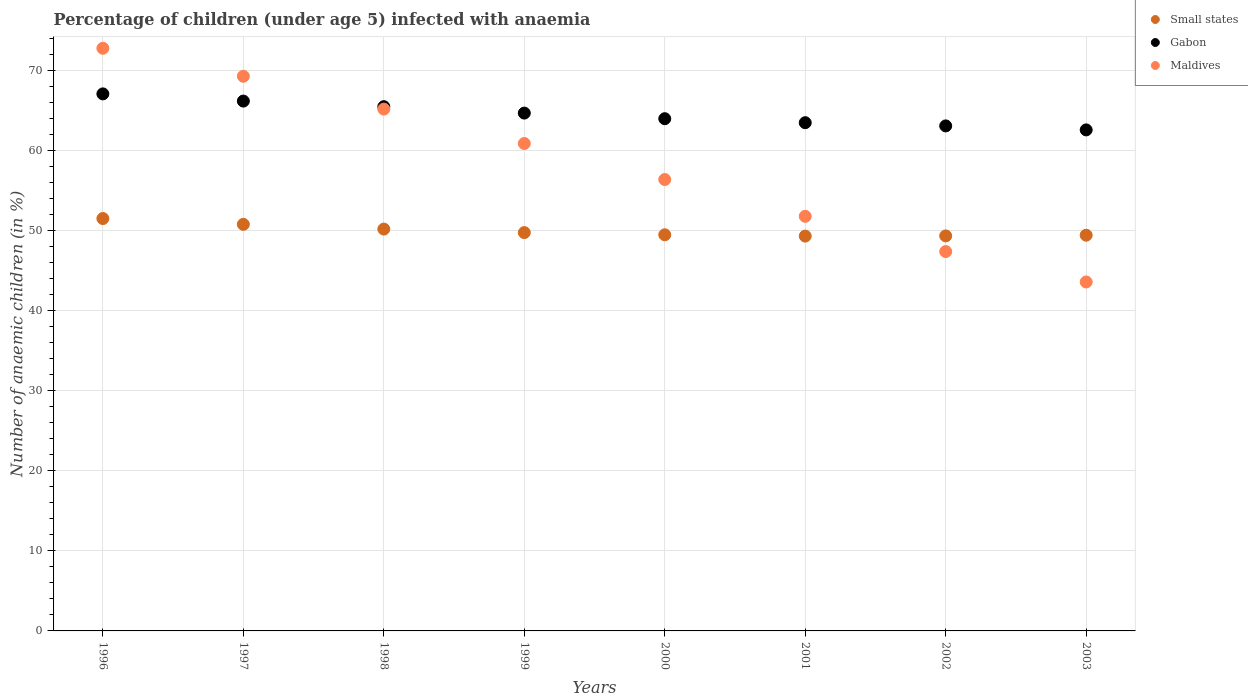What is the percentage of children infected with anaemia in in Small states in 2000?
Make the answer very short. 49.49. Across all years, what is the maximum percentage of children infected with anaemia in in Maldives?
Your answer should be very brief. 72.8. Across all years, what is the minimum percentage of children infected with anaemia in in Small states?
Your answer should be compact. 49.33. In which year was the percentage of children infected with anaemia in in Maldives maximum?
Keep it short and to the point. 1996. In which year was the percentage of children infected with anaemia in in Small states minimum?
Ensure brevity in your answer.  2001. What is the total percentage of children infected with anaemia in in Maldives in the graph?
Your response must be concise. 467.4. What is the difference between the percentage of children infected with anaemia in in Maldives in 1996 and that in 1997?
Your answer should be compact. 3.5. What is the difference between the percentage of children infected with anaemia in in Small states in 2003 and the percentage of children infected with anaemia in in Maldives in 1997?
Your answer should be very brief. -19.86. What is the average percentage of children infected with anaemia in in Maldives per year?
Provide a short and direct response. 58.42. In the year 1998, what is the difference between the percentage of children infected with anaemia in in Small states and percentage of children infected with anaemia in in Maldives?
Keep it short and to the point. -14.99. In how many years, is the percentage of children infected with anaemia in in Small states greater than 16 %?
Your answer should be compact. 8. What is the ratio of the percentage of children infected with anaemia in in Gabon in 1997 to that in 1999?
Provide a short and direct response. 1.02. Is the difference between the percentage of children infected with anaemia in in Small states in 1996 and 1998 greater than the difference between the percentage of children infected with anaemia in in Maldives in 1996 and 1998?
Offer a terse response. No. What is the difference between the highest and the second highest percentage of children infected with anaemia in in Small states?
Give a very brief answer. 0.73. What is the difference between the highest and the lowest percentage of children infected with anaemia in in Gabon?
Your answer should be very brief. 4.5. Does the percentage of children infected with anaemia in in Gabon monotonically increase over the years?
Offer a terse response. No. Is the percentage of children infected with anaemia in in Small states strictly less than the percentage of children infected with anaemia in in Maldives over the years?
Your answer should be compact. No. What is the difference between two consecutive major ticks on the Y-axis?
Your response must be concise. 10. Does the graph contain grids?
Offer a very short reply. Yes. Where does the legend appear in the graph?
Offer a terse response. Top right. How many legend labels are there?
Ensure brevity in your answer.  3. What is the title of the graph?
Provide a succinct answer. Percentage of children (under age 5) infected with anaemia. What is the label or title of the X-axis?
Provide a short and direct response. Years. What is the label or title of the Y-axis?
Keep it short and to the point. Number of anaemic children (in %). What is the Number of anaemic children (in %) of Small states in 1996?
Give a very brief answer. 51.52. What is the Number of anaemic children (in %) of Gabon in 1996?
Give a very brief answer. 67.1. What is the Number of anaemic children (in %) in Maldives in 1996?
Keep it short and to the point. 72.8. What is the Number of anaemic children (in %) in Small states in 1997?
Provide a succinct answer. 50.8. What is the Number of anaemic children (in %) in Gabon in 1997?
Make the answer very short. 66.2. What is the Number of anaemic children (in %) of Maldives in 1997?
Keep it short and to the point. 69.3. What is the Number of anaemic children (in %) of Small states in 1998?
Ensure brevity in your answer.  50.21. What is the Number of anaemic children (in %) of Gabon in 1998?
Your answer should be very brief. 65.5. What is the Number of anaemic children (in %) of Maldives in 1998?
Your response must be concise. 65.2. What is the Number of anaemic children (in %) of Small states in 1999?
Ensure brevity in your answer.  49.77. What is the Number of anaemic children (in %) in Gabon in 1999?
Your answer should be very brief. 64.7. What is the Number of anaemic children (in %) of Maldives in 1999?
Provide a short and direct response. 60.9. What is the Number of anaemic children (in %) in Small states in 2000?
Make the answer very short. 49.49. What is the Number of anaemic children (in %) in Maldives in 2000?
Your response must be concise. 56.4. What is the Number of anaemic children (in %) in Small states in 2001?
Make the answer very short. 49.33. What is the Number of anaemic children (in %) of Gabon in 2001?
Give a very brief answer. 63.5. What is the Number of anaemic children (in %) of Maldives in 2001?
Keep it short and to the point. 51.8. What is the Number of anaemic children (in %) of Small states in 2002?
Your response must be concise. 49.36. What is the Number of anaemic children (in %) of Gabon in 2002?
Make the answer very short. 63.1. What is the Number of anaemic children (in %) of Maldives in 2002?
Provide a short and direct response. 47.4. What is the Number of anaemic children (in %) in Small states in 2003?
Make the answer very short. 49.44. What is the Number of anaemic children (in %) in Gabon in 2003?
Keep it short and to the point. 62.6. What is the Number of anaemic children (in %) of Maldives in 2003?
Offer a terse response. 43.6. Across all years, what is the maximum Number of anaemic children (in %) of Small states?
Make the answer very short. 51.52. Across all years, what is the maximum Number of anaemic children (in %) in Gabon?
Offer a terse response. 67.1. Across all years, what is the maximum Number of anaemic children (in %) of Maldives?
Your answer should be compact. 72.8. Across all years, what is the minimum Number of anaemic children (in %) of Small states?
Your answer should be very brief. 49.33. Across all years, what is the minimum Number of anaemic children (in %) of Gabon?
Your response must be concise. 62.6. Across all years, what is the minimum Number of anaemic children (in %) in Maldives?
Provide a succinct answer. 43.6. What is the total Number of anaemic children (in %) in Small states in the graph?
Provide a succinct answer. 399.92. What is the total Number of anaemic children (in %) in Gabon in the graph?
Your answer should be compact. 516.7. What is the total Number of anaemic children (in %) of Maldives in the graph?
Keep it short and to the point. 467.4. What is the difference between the Number of anaemic children (in %) in Small states in 1996 and that in 1997?
Your response must be concise. 0.73. What is the difference between the Number of anaemic children (in %) in Gabon in 1996 and that in 1997?
Your answer should be very brief. 0.9. What is the difference between the Number of anaemic children (in %) in Small states in 1996 and that in 1998?
Provide a succinct answer. 1.32. What is the difference between the Number of anaemic children (in %) in Gabon in 1996 and that in 1998?
Keep it short and to the point. 1.6. What is the difference between the Number of anaemic children (in %) in Small states in 1996 and that in 1999?
Offer a very short reply. 1.76. What is the difference between the Number of anaemic children (in %) of Gabon in 1996 and that in 1999?
Your answer should be compact. 2.4. What is the difference between the Number of anaemic children (in %) of Small states in 1996 and that in 2000?
Keep it short and to the point. 2.03. What is the difference between the Number of anaemic children (in %) of Gabon in 1996 and that in 2000?
Provide a succinct answer. 3.1. What is the difference between the Number of anaemic children (in %) in Maldives in 1996 and that in 2000?
Make the answer very short. 16.4. What is the difference between the Number of anaemic children (in %) in Small states in 1996 and that in 2001?
Make the answer very short. 2.19. What is the difference between the Number of anaemic children (in %) in Small states in 1996 and that in 2002?
Offer a very short reply. 2.17. What is the difference between the Number of anaemic children (in %) in Gabon in 1996 and that in 2002?
Your answer should be compact. 4. What is the difference between the Number of anaemic children (in %) of Maldives in 1996 and that in 2002?
Your response must be concise. 25.4. What is the difference between the Number of anaemic children (in %) in Small states in 1996 and that in 2003?
Your answer should be compact. 2.08. What is the difference between the Number of anaemic children (in %) in Gabon in 1996 and that in 2003?
Your response must be concise. 4.5. What is the difference between the Number of anaemic children (in %) of Maldives in 1996 and that in 2003?
Provide a succinct answer. 29.2. What is the difference between the Number of anaemic children (in %) in Small states in 1997 and that in 1998?
Provide a succinct answer. 0.59. What is the difference between the Number of anaemic children (in %) in Gabon in 1997 and that in 1998?
Your answer should be very brief. 0.7. What is the difference between the Number of anaemic children (in %) in Maldives in 1997 and that in 1998?
Give a very brief answer. 4.1. What is the difference between the Number of anaemic children (in %) of Small states in 1997 and that in 1999?
Make the answer very short. 1.03. What is the difference between the Number of anaemic children (in %) in Gabon in 1997 and that in 1999?
Make the answer very short. 1.5. What is the difference between the Number of anaemic children (in %) in Small states in 1997 and that in 2000?
Your response must be concise. 1.3. What is the difference between the Number of anaemic children (in %) of Maldives in 1997 and that in 2000?
Offer a terse response. 12.9. What is the difference between the Number of anaemic children (in %) in Small states in 1997 and that in 2001?
Your response must be concise. 1.46. What is the difference between the Number of anaemic children (in %) in Maldives in 1997 and that in 2001?
Your response must be concise. 17.5. What is the difference between the Number of anaemic children (in %) of Small states in 1997 and that in 2002?
Your response must be concise. 1.44. What is the difference between the Number of anaemic children (in %) of Maldives in 1997 and that in 2002?
Make the answer very short. 21.9. What is the difference between the Number of anaemic children (in %) in Small states in 1997 and that in 2003?
Provide a succinct answer. 1.36. What is the difference between the Number of anaemic children (in %) of Gabon in 1997 and that in 2003?
Offer a terse response. 3.6. What is the difference between the Number of anaemic children (in %) in Maldives in 1997 and that in 2003?
Your answer should be compact. 25.7. What is the difference between the Number of anaemic children (in %) in Small states in 1998 and that in 1999?
Provide a succinct answer. 0.44. What is the difference between the Number of anaemic children (in %) of Gabon in 1998 and that in 1999?
Ensure brevity in your answer.  0.8. What is the difference between the Number of anaemic children (in %) in Maldives in 1998 and that in 1999?
Offer a terse response. 4.3. What is the difference between the Number of anaemic children (in %) of Small states in 1998 and that in 2000?
Your answer should be compact. 0.71. What is the difference between the Number of anaemic children (in %) of Small states in 1998 and that in 2001?
Your response must be concise. 0.87. What is the difference between the Number of anaemic children (in %) in Small states in 1998 and that in 2002?
Keep it short and to the point. 0.85. What is the difference between the Number of anaemic children (in %) of Small states in 1998 and that in 2003?
Offer a very short reply. 0.76. What is the difference between the Number of anaemic children (in %) of Gabon in 1998 and that in 2003?
Ensure brevity in your answer.  2.9. What is the difference between the Number of anaemic children (in %) in Maldives in 1998 and that in 2003?
Offer a very short reply. 21.6. What is the difference between the Number of anaemic children (in %) of Small states in 1999 and that in 2000?
Give a very brief answer. 0.27. What is the difference between the Number of anaemic children (in %) of Maldives in 1999 and that in 2000?
Keep it short and to the point. 4.5. What is the difference between the Number of anaemic children (in %) of Small states in 1999 and that in 2001?
Your answer should be very brief. 0.44. What is the difference between the Number of anaemic children (in %) in Maldives in 1999 and that in 2001?
Your answer should be very brief. 9.1. What is the difference between the Number of anaemic children (in %) in Small states in 1999 and that in 2002?
Provide a short and direct response. 0.41. What is the difference between the Number of anaemic children (in %) in Maldives in 1999 and that in 2002?
Provide a succinct answer. 13.5. What is the difference between the Number of anaemic children (in %) of Small states in 1999 and that in 2003?
Provide a short and direct response. 0.33. What is the difference between the Number of anaemic children (in %) in Maldives in 1999 and that in 2003?
Offer a very short reply. 17.3. What is the difference between the Number of anaemic children (in %) in Small states in 2000 and that in 2001?
Offer a terse response. 0.16. What is the difference between the Number of anaemic children (in %) in Gabon in 2000 and that in 2001?
Provide a short and direct response. 0.5. What is the difference between the Number of anaemic children (in %) in Maldives in 2000 and that in 2001?
Your answer should be compact. 4.6. What is the difference between the Number of anaemic children (in %) in Small states in 2000 and that in 2002?
Offer a terse response. 0.14. What is the difference between the Number of anaemic children (in %) in Small states in 2000 and that in 2003?
Ensure brevity in your answer.  0.05. What is the difference between the Number of anaemic children (in %) in Small states in 2001 and that in 2002?
Offer a very short reply. -0.02. What is the difference between the Number of anaemic children (in %) of Gabon in 2001 and that in 2002?
Make the answer very short. 0.4. What is the difference between the Number of anaemic children (in %) of Small states in 2001 and that in 2003?
Your answer should be compact. -0.11. What is the difference between the Number of anaemic children (in %) in Gabon in 2001 and that in 2003?
Your answer should be compact. 0.9. What is the difference between the Number of anaemic children (in %) of Maldives in 2001 and that in 2003?
Your answer should be very brief. 8.2. What is the difference between the Number of anaemic children (in %) of Small states in 2002 and that in 2003?
Offer a very short reply. -0.09. What is the difference between the Number of anaemic children (in %) of Small states in 1996 and the Number of anaemic children (in %) of Gabon in 1997?
Your answer should be very brief. -14.68. What is the difference between the Number of anaemic children (in %) in Small states in 1996 and the Number of anaemic children (in %) in Maldives in 1997?
Keep it short and to the point. -17.78. What is the difference between the Number of anaemic children (in %) in Gabon in 1996 and the Number of anaemic children (in %) in Maldives in 1997?
Your answer should be compact. -2.2. What is the difference between the Number of anaemic children (in %) in Small states in 1996 and the Number of anaemic children (in %) in Gabon in 1998?
Make the answer very short. -13.98. What is the difference between the Number of anaemic children (in %) of Small states in 1996 and the Number of anaemic children (in %) of Maldives in 1998?
Give a very brief answer. -13.68. What is the difference between the Number of anaemic children (in %) in Gabon in 1996 and the Number of anaemic children (in %) in Maldives in 1998?
Make the answer very short. 1.9. What is the difference between the Number of anaemic children (in %) of Small states in 1996 and the Number of anaemic children (in %) of Gabon in 1999?
Give a very brief answer. -13.18. What is the difference between the Number of anaemic children (in %) in Small states in 1996 and the Number of anaemic children (in %) in Maldives in 1999?
Ensure brevity in your answer.  -9.38. What is the difference between the Number of anaemic children (in %) in Small states in 1996 and the Number of anaemic children (in %) in Gabon in 2000?
Your answer should be compact. -12.48. What is the difference between the Number of anaemic children (in %) in Small states in 1996 and the Number of anaemic children (in %) in Maldives in 2000?
Provide a short and direct response. -4.88. What is the difference between the Number of anaemic children (in %) of Gabon in 1996 and the Number of anaemic children (in %) of Maldives in 2000?
Make the answer very short. 10.7. What is the difference between the Number of anaemic children (in %) in Small states in 1996 and the Number of anaemic children (in %) in Gabon in 2001?
Offer a very short reply. -11.98. What is the difference between the Number of anaemic children (in %) in Small states in 1996 and the Number of anaemic children (in %) in Maldives in 2001?
Make the answer very short. -0.28. What is the difference between the Number of anaemic children (in %) of Gabon in 1996 and the Number of anaemic children (in %) of Maldives in 2001?
Ensure brevity in your answer.  15.3. What is the difference between the Number of anaemic children (in %) of Small states in 1996 and the Number of anaemic children (in %) of Gabon in 2002?
Your answer should be compact. -11.58. What is the difference between the Number of anaemic children (in %) in Small states in 1996 and the Number of anaemic children (in %) in Maldives in 2002?
Your response must be concise. 4.12. What is the difference between the Number of anaemic children (in %) in Small states in 1996 and the Number of anaemic children (in %) in Gabon in 2003?
Your answer should be very brief. -11.08. What is the difference between the Number of anaemic children (in %) in Small states in 1996 and the Number of anaemic children (in %) in Maldives in 2003?
Offer a terse response. 7.92. What is the difference between the Number of anaemic children (in %) of Gabon in 1996 and the Number of anaemic children (in %) of Maldives in 2003?
Offer a terse response. 23.5. What is the difference between the Number of anaemic children (in %) in Small states in 1997 and the Number of anaemic children (in %) in Gabon in 1998?
Offer a terse response. -14.7. What is the difference between the Number of anaemic children (in %) of Small states in 1997 and the Number of anaemic children (in %) of Maldives in 1998?
Make the answer very short. -14.4. What is the difference between the Number of anaemic children (in %) of Small states in 1997 and the Number of anaemic children (in %) of Gabon in 1999?
Your response must be concise. -13.9. What is the difference between the Number of anaemic children (in %) of Small states in 1997 and the Number of anaemic children (in %) of Maldives in 1999?
Make the answer very short. -10.1. What is the difference between the Number of anaemic children (in %) in Gabon in 1997 and the Number of anaemic children (in %) in Maldives in 1999?
Your answer should be compact. 5.3. What is the difference between the Number of anaemic children (in %) of Small states in 1997 and the Number of anaemic children (in %) of Gabon in 2000?
Make the answer very short. -13.2. What is the difference between the Number of anaemic children (in %) in Small states in 1997 and the Number of anaemic children (in %) in Maldives in 2000?
Provide a short and direct response. -5.6. What is the difference between the Number of anaemic children (in %) in Small states in 1997 and the Number of anaemic children (in %) in Gabon in 2001?
Offer a terse response. -12.7. What is the difference between the Number of anaemic children (in %) in Small states in 1997 and the Number of anaemic children (in %) in Maldives in 2001?
Your answer should be very brief. -1. What is the difference between the Number of anaemic children (in %) of Gabon in 1997 and the Number of anaemic children (in %) of Maldives in 2001?
Keep it short and to the point. 14.4. What is the difference between the Number of anaemic children (in %) in Small states in 1997 and the Number of anaemic children (in %) in Gabon in 2002?
Provide a short and direct response. -12.3. What is the difference between the Number of anaemic children (in %) in Small states in 1997 and the Number of anaemic children (in %) in Maldives in 2002?
Give a very brief answer. 3.4. What is the difference between the Number of anaemic children (in %) of Gabon in 1997 and the Number of anaemic children (in %) of Maldives in 2002?
Give a very brief answer. 18.8. What is the difference between the Number of anaemic children (in %) of Small states in 1997 and the Number of anaemic children (in %) of Gabon in 2003?
Ensure brevity in your answer.  -11.8. What is the difference between the Number of anaemic children (in %) in Small states in 1997 and the Number of anaemic children (in %) in Maldives in 2003?
Your answer should be very brief. 7.2. What is the difference between the Number of anaemic children (in %) of Gabon in 1997 and the Number of anaemic children (in %) of Maldives in 2003?
Provide a short and direct response. 22.6. What is the difference between the Number of anaemic children (in %) in Small states in 1998 and the Number of anaemic children (in %) in Gabon in 1999?
Your response must be concise. -14.49. What is the difference between the Number of anaemic children (in %) in Small states in 1998 and the Number of anaemic children (in %) in Maldives in 1999?
Offer a terse response. -10.69. What is the difference between the Number of anaemic children (in %) in Gabon in 1998 and the Number of anaemic children (in %) in Maldives in 1999?
Provide a short and direct response. 4.6. What is the difference between the Number of anaemic children (in %) in Small states in 1998 and the Number of anaemic children (in %) in Gabon in 2000?
Give a very brief answer. -13.79. What is the difference between the Number of anaemic children (in %) of Small states in 1998 and the Number of anaemic children (in %) of Maldives in 2000?
Your answer should be very brief. -6.19. What is the difference between the Number of anaemic children (in %) of Small states in 1998 and the Number of anaemic children (in %) of Gabon in 2001?
Offer a terse response. -13.29. What is the difference between the Number of anaemic children (in %) in Small states in 1998 and the Number of anaemic children (in %) in Maldives in 2001?
Keep it short and to the point. -1.59. What is the difference between the Number of anaemic children (in %) of Small states in 1998 and the Number of anaemic children (in %) of Gabon in 2002?
Offer a very short reply. -12.89. What is the difference between the Number of anaemic children (in %) in Small states in 1998 and the Number of anaemic children (in %) in Maldives in 2002?
Keep it short and to the point. 2.81. What is the difference between the Number of anaemic children (in %) of Small states in 1998 and the Number of anaemic children (in %) of Gabon in 2003?
Ensure brevity in your answer.  -12.39. What is the difference between the Number of anaemic children (in %) in Small states in 1998 and the Number of anaemic children (in %) in Maldives in 2003?
Offer a terse response. 6.61. What is the difference between the Number of anaemic children (in %) of Gabon in 1998 and the Number of anaemic children (in %) of Maldives in 2003?
Ensure brevity in your answer.  21.9. What is the difference between the Number of anaemic children (in %) in Small states in 1999 and the Number of anaemic children (in %) in Gabon in 2000?
Your answer should be very brief. -14.23. What is the difference between the Number of anaemic children (in %) of Small states in 1999 and the Number of anaemic children (in %) of Maldives in 2000?
Your response must be concise. -6.63. What is the difference between the Number of anaemic children (in %) of Small states in 1999 and the Number of anaemic children (in %) of Gabon in 2001?
Offer a terse response. -13.73. What is the difference between the Number of anaemic children (in %) in Small states in 1999 and the Number of anaemic children (in %) in Maldives in 2001?
Your response must be concise. -2.03. What is the difference between the Number of anaemic children (in %) in Small states in 1999 and the Number of anaemic children (in %) in Gabon in 2002?
Your answer should be very brief. -13.33. What is the difference between the Number of anaemic children (in %) of Small states in 1999 and the Number of anaemic children (in %) of Maldives in 2002?
Your answer should be very brief. 2.37. What is the difference between the Number of anaemic children (in %) in Small states in 1999 and the Number of anaemic children (in %) in Gabon in 2003?
Keep it short and to the point. -12.83. What is the difference between the Number of anaemic children (in %) of Small states in 1999 and the Number of anaemic children (in %) of Maldives in 2003?
Your answer should be very brief. 6.17. What is the difference between the Number of anaemic children (in %) of Gabon in 1999 and the Number of anaemic children (in %) of Maldives in 2003?
Provide a short and direct response. 21.1. What is the difference between the Number of anaemic children (in %) of Small states in 2000 and the Number of anaemic children (in %) of Gabon in 2001?
Your answer should be compact. -14.01. What is the difference between the Number of anaemic children (in %) in Small states in 2000 and the Number of anaemic children (in %) in Maldives in 2001?
Offer a terse response. -2.31. What is the difference between the Number of anaemic children (in %) of Small states in 2000 and the Number of anaemic children (in %) of Gabon in 2002?
Give a very brief answer. -13.61. What is the difference between the Number of anaemic children (in %) of Small states in 2000 and the Number of anaemic children (in %) of Maldives in 2002?
Make the answer very short. 2.09. What is the difference between the Number of anaemic children (in %) of Small states in 2000 and the Number of anaemic children (in %) of Gabon in 2003?
Keep it short and to the point. -13.11. What is the difference between the Number of anaemic children (in %) in Small states in 2000 and the Number of anaemic children (in %) in Maldives in 2003?
Your response must be concise. 5.89. What is the difference between the Number of anaemic children (in %) of Gabon in 2000 and the Number of anaemic children (in %) of Maldives in 2003?
Offer a terse response. 20.4. What is the difference between the Number of anaemic children (in %) in Small states in 2001 and the Number of anaemic children (in %) in Gabon in 2002?
Offer a very short reply. -13.77. What is the difference between the Number of anaemic children (in %) in Small states in 2001 and the Number of anaemic children (in %) in Maldives in 2002?
Ensure brevity in your answer.  1.93. What is the difference between the Number of anaemic children (in %) of Gabon in 2001 and the Number of anaemic children (in %) of Maldives in 2002?
Ensure brevity in your answer.  16.1. What is the difference between the Number of anaemic children (in %) in Small states in 2001 and the Number of anaemic children (in %) in Gabon in 2003?
Provide a short and direct response. -13.27. What is the difference between the Number of anaemic children (in %) in Small states in 2001 and the Number of anaemic children (in %) in Maldives in 2003?
Your response must be concise. 5.73. What is the difference between the Number of anaemic children (in %) in Gabon in 2001 and the Number of anaemic children (in %) in Maldives in 2003?
Give a very brief answer. 19.9. What is the difference between the Number of anaemic children (in %) in Small states in 2002 and the Number of anaemic children (in %) in Gabon in 2003?
Offer a terse response. -13.24. What is the difference between the Number of anaemic children (in %) in Small states in 2002 and the Number of anaemic children (in %) in Maldives in 2003?
Give a very brief answer. 5.76. What is the average Number of anaemic children (in %) of Small states per year?
Your response must be concise. 49.99. What is the average Number of anaemic children (in %) in Gabon per year?
Your response must be concise. 64.59. What is the average Number of anaemic children (in %) in Maldives per year?
Offer a very short reply. 58.42. In the year 1996, what is the difference between the Number of anaemic children (in %) in Small states and Number of anaemic children (in %) in Gabon?
Give a very brief answer. -15.58. In the year 1996, what is the difference between the Number of anaemic children (in %) of Small states and Number of anaemic children (in %) of Maldives?
Offer a very short reply. -21.28. In the year 1996, what is the difference between the Number of anaemic children (in %) of Gabon and Number of anaemic children (in %) of Maldives?
Keep it short and to the point. -5.7. In the year 1997, what is the difference between the Number of anaemic children (in %) of Small states and Number of anaemic children (in %) of Gabon?
Provide a short and direct response. -15.4. In the year 1997, what is the difference between the Number of anaemic children (in %) in Small states and Number of anaemic children (in %) in Maldives?
Make the answer very short. -18.5. In the year 1997, what is the difference between the Number of anaemic children (in %) in Gabon and Number of anaemic children (in %) in Maldives?
Offer a terse response. -3.1. In the year 1998, what is the difference between the Number of anaemic children (in %) of Small states and Number of anaemic children (in %) of Gabon?
Your answer should be compact. -15.29. In the year 1998, what is the difference between the Number of anaemic children (in %) in Small states and Number of anaemic children (in %) in Maldives?
Ensure brevity in your answer.  -14.99. In the year 1999, what is the difference between the Number of anaemic children (in %) of Small states and Number of anaemic children (in %) of Gabon?
Provide a succinct answer. -14.93. In the year 1999, what is the difference between the Number of anaemic children (in %) in Small states and Number of anaemic children (in %) in Maldives?
Make the answer very short. -11.13. In the year 1999, what is the difference between the Number of anaemic children (in %) of Gabon and Number of anaemic children (in %) of Maldives?
Keep it short and to the point. 3.8. In the year 2000, what is the difference between the Number of anaemic children (in %) of Small states and Number of anaemic children (in %) of Gabon?
Ensure brevity in your answer.  -14.51. In the year 2000, what is the difference between the Number of anaemic children (in %) of Small states and Number of anaemic children (in %) of Maldives?
Your answer should be compact. -6.91. In the year 2001, what is the difference between the Number of anaemic children (in %) of Small states and Number of anaemic children (in %) of Gabon?
Make the answer very short. -14.17. In the year 2001, what is the difference between the Number of anaemic children (in %) of Small states and Number of anaemic children (in %) of Maldives?
Provide a short and direct response. -2.47. In the year 2002, what is the difference between the Number of anaemic children (in %) in Small states and Number of anaemic children (in %) in Gabon?
Offer a terse response. -13.74. In the year 2002, what is the difference between the Number of anaemic children (in %) in Small states and Number of anaemic children (in %) in Maldives?
Provide a short and direct response. 1.96. In the year 2003, what is the difference between the Number of anaemic children (in %) in Small states and Number of anaemic children (in %) in Gabon?
Offer a very short reply. -13.16. In the year 2003, what is the difference between the Number of anaemic children (in %) of Small states and Number of anaemic children (in %) of Maldives?
Give a very brief answer. 5.84. In the year 2003, what is the difference between the Number of anaemic children (in %) of Gabon and Number of anaemic children (in %) of Maldives?
Ensure brevity in your answer.  19. What is the ratio of the Number of anaemic children (in %) in Small states in 1996 to that in 1997?
Keep it short and to the point. 1.01. What is the ratio of the Number of anaemic children (in %) of Gabon in 1996 to that in 1997?
Offer a terse response. 1.01. What is the ratio of the Number of anaemic children (in %) of Maldives in 1996 to that in 1997?
Make the answer very short. 1.05. What is the ratio of the Number of anaemic children (in %) in Small states in 1996 to that in 1998?
Ensure brevity in your answer.  1.03. What is the ratio of the Number of anaemic children (in %) in Gabon in 1996 to that in 1998?
Make the answer very short. 1.02. What is the ratio of the Number of anaemic children (in %) in Maldives in 1996 to that in 1998?
Your answer should be very brief. 1.12. What is the ratio of the Number of anaemic children (in %) in Small states in 1996 to that in 1999?
Ensure brevity in your answer.  1.04. What is the ratio of the Number of anaemic children (in %) of Gabon in 1996 to that in 1999?
Your answer should be compact. 1.04. What is the ratio of the Number of anaemic children (in %) of Maldives in 1996 to that in 1999?
Give a very brief answer. 1.2. What is the ratio of the Number of anaemic children (in %) in Small states in 1996 to that in 2000?
Give a very brief answer. 1.04. What is the ratio of the Number of anaemic children (in %) in Gabon in 1996 to that in 2000?
Your response must be concise. 1.05. What is the ratio of the Number of anaemic children (in %) in Maldives in 1996 to that in 2000?
Your answer should be compact. 1.29. What is the ratio of the Number of anaemic children (in %) in Small states in 1996 to that in 2001?
Offer a terse response. 1.04. What is the ratio of the Number of anaemic children (in %) in Gabon in 1996 to that in 2001?
Keep it short and to the point. 1.06. What is the ratio of the Number of anaemic children (in %) of Maldives in 1996 to that in 2001?
Ensure brevity in your answer.  1.41. What is the ratio of the Number of anaemic children (in %) of Small states in 1996 to that in 2002?
Give a very brief answer. 1.04. What is the ratio of the Number of anaemic children (in %) in Gabon in 1996 to that in 2002?
Provide a succinct answer. 1.06. What is the ratio of the Number of anaemic children (in %) of Maldives in 1996 to that in 2002?
Make the answer very short. 1.54. What is the ratio of the Number of anaemic children (in %) of Small states in 1996 to that in 2003?
Offer a very short reply. 1.04. What is the ratio of the Number of anaemic children (in %) of Gabon in 1996 to that in 2003?
Provide a succinct answer. 1.07. What is the ratio of the Number of anaemic children (in %) in Maldives in 1996 to that in 2003?
Keep it short and to the point. 1.67. What is the ratio of the Number of anaemic children (in %) in Small states in 1997 to that in 1998?
Your response must be concise. 1.01. What is the ratio of the Number of anaemic children (in %) in Gabon in 1997 to that in 1998?
Your answer should be compact. 1.01. What is the ratio of the Number of anaemic children (in %) in Maldives in 1997 to that in 1998?
Ensure brevity in your answer.  1.06. What is the ratio of the Number of anaemic children (in %) in Small states in 1997 to that in 1999?
Give a very brief answer. 1.02. What is the ratio of the Number of anaemic children (in %) of Gabon in 1997 to that in 1999?
Your answer should be compact. 1.02. What is the ratio of the Number of anaemic children (in %) in Maldives in 1997 to that in 1999?
Your response must be concise. 1.14. What is the ratio of the Number of anaemic children (in %) in Small states in 1997 to that in 2000?
Your answer should be compact. 1.03. What is the ratio of the Number of anaemic children (in %) of Gabon in 1997 to that in 2000?
Offer a very short reply. 1.03. What is the ratio of the Number of anaemic children (in %) in Maldives in 1997 to that in 2000?
Provide a succinct answer. 1.23. What is the ratio of the Number of anaemic children (in %) of Small states in 1997 to that in 2001?
Ensure brevity in your answer.  1.03. What is the ratio of the Number of anaemic children (in %) in Gabon in 1997 to that in 2001?
Ensure brevity in your answer.  1.04. What is the ratio of the Number of anaemic children (in %) of Maldives in 1997 to that in 2001?
Your answer should be compact. 1.34. What is the ratio of the Number of anaemic children (in %) of Small states in 1997 to that in 2002?
Keep it short and to the point. 1.03. What is the ratio of the Number of anaemic children (in %) of Gabon in 1997 to that in 2002?
Ensure brevity in your answer.  1.05. What is the ratio of the Number of anaemic children (in %) in Maldives in 1997 to that in 2002?
Give a very brief answer. 1.46. What is the ratio of the Number of anaemic children (in %) in Small states in 1997 to that in 2003?
Offer a very short reply. 1.03. What is the ratio of the Number of anaemic children (in %) in Gabon in 1997 to that in 2003?
Make the answer very short. 1.06. What is the ratio of the Number of anaemic children (in %) in Maldives in 1997 to that in 2003?
Offer a very short reply. 1.59. What is the ratio of the Number of anaemic children (in %) of Small states in 1998 to that in 1999?
Your answer should be compact. 1.01. What is the ratio of the Number of anaemic children (in %) in Gabon in 1998 to that in 1999?
Keep it short and to the point. 1.01. What is the ratio of the Number of anaemic children (in %) in Maldives in 1998 to that in 1999?
Give a very brief answer. 1.07. What is the ratio of the Number of anaemic children (in %) in Small states in 1998 to that in 2000?
Your response must be concise. 1.01. What is the ratio of the Number of anaemic children (in %) of Gabon in 1998 to that in 2000?
Provide a short and direct response. 1.02. What is the ratio of the Number of anaemic children (in %) in Maldives in 1998 to that in 2000?
Offer a terse response. 1.16. What is the ratio of the Number of anaemic children (in %) in Small states in 1998 to that in 2001?
Offer a terse response. 1.02. What is the ratio of the Number of anaemic children (in %) in Gabon in 1998 to that in 2001?
Keep it short and to the point. 1.03. What is the ratio of the Number of anaemic children (in %) of Maldives in 1998 to that in 2001?
Offer a terse response. 1.26. What is the ratio of the Number of anaemic children (in %) in Small states in 1998 to that in 2002?
Give a very brief answer. 1.02. What is the ratio of the Number of anaemic children (in %) in Gabon in 1998 to that in 2002?
Give a very brief answer. 1.04. What is the ratio of the Number of anaemic children (in %) in Maldives in 1998 to that in 2002?
Ensure brevity in your answer.  1.38. What is the ratio of the Number of anaemic children (in %) in Small states in 1998 to that in 2003?
Your response must be concise. 1.02. What is the ratio of the Number of anaemic children (in %) in Gabon in 1998 to that in 2003?
Provide a short and direct response. 1.05. What is the ratio of the Number of anaemic children (in %) in Maldives in 1998 to that in 2003?
Give a very brief answer. 1.5. What is the ratio of the Number of anaemic children (in %) of Gabon in 1999 to that in 2000?
Your answer should be very brief. 1.01. What is the ratio of the Number of anaemic children (in %) of Maldives in 1999 to that in 2000?
Ensure brevity in your answer.  1.08. What is the ratio of the Number of anaemic children (in %) in Small states in 1999 to that in 2001?
Make the answer very short. 1.01. What is the ratio of the Number of anaemic children (in %) in Gabon in 1999 to that in 2001?
Give a very brief answer. 1.02. What is the ratio of the Number of anaemic children (in %) of Maldives in 1999 to that in 2001?
Your answer should be compact. 1.18. What is the ratio of the Number of anaemic children (in %) of Small states in 1999 to that in 2002?
Your response must be concise. 1.01. What is the ratio of the Number of anaemic children (in %) of Gabon in 1999 to that in 2002?
Your response must be concise. 1.03. What is the ratio of the Number of anaemic children (in %) of Maldives in 1999 to that in 2002?
Provide a succinct answer. 1.28. What is the ratio of the Number of anaemic children (in %) of Small states in 1999 to that in 2003?
Offer a very short reply. 1.01. What is the ratio of the Number of anaemic children (in %) in Gabon in 1999 to that in 2003?
Offer a terse response. 1.03. What is the ratio of the Number of anaemic children (in %) in Maldives in 1999 to that in 2003?
Your answer should be very brief. 1.4. What is the ratio of the Number of anaemic children (in %) in Gabon in 2000 to that in 2001?
Your response must be concise. 1.01. What is the ratio of the Number of anaemic children (in %) of Maldives in 2000 to that in 2001?
Give a very brief answer. 1.09. What is the ratio of the Number of anaemic children (in %) of Gabon in 2000 to that in 2002?
Give a very brief answer. 1.01. What is the ratio of the Number of anaemic children (in %) in Maldives in 2000 to that in 2002?
Provide a short and direct response. 1.19. What is the ratio of the Number of anaemic children (in %) of Small states in 2000 to that in 2003?
Provide a short and direct response. 1. What is the ratio of the Number of anaemic children (in %) in Gabon in 2000 to that in 2003?
Offer a terse response. 1.02. What is the ratio of the Number of anaemic children (in %) in Maldives in 2000 to that in 2003?
Ensure brevity in your answer.  1.29. What is the ratio of the Number of anaemic children (in %) of Gabon in 2001 to that in 2002?
Give a very brief answer. 1.01. What is the ratio of the Number of anaemic children (in %) in Maldives in 2001 to that in 2002?
Make the answer very short. 1.09. What is the ratio of the Number of anaemic children (in %) of Gabon in 2001 to that in 2003?
Ensure brevity in your answer.  1.01. What is the ratio of the Number of anaemic children (in %) of Maldives in 2001 to that in 2003?
Make the answer very short. 1.19. What is the ratio of the Number of anaemic children (in %) in Small states in 2002 to that in 2003?
Provide a short and direct response. 1. What is the ratio of the Number of anaemic children (in %) in Maldives in 2002 to that in 2003?
Keep it short and to the point. 1.09. What is the difference between the highest and the second highest Number of anaemic children (in %) in Small states?
Your answer should be compact. 0.73. What is the difference between the highest and the second highest Number of anaemic children (in %) in Gabon?
Give a very brief answer. 0.9. What is the difference between the highest and the lowest Number of anaemic children (in %) in Small states?
Keep it short and to the point. 2.19. What is the difference between the highest and the lowest Number of anaemic children (in %) of Maldives?
Offer a terse response. 29.2. 